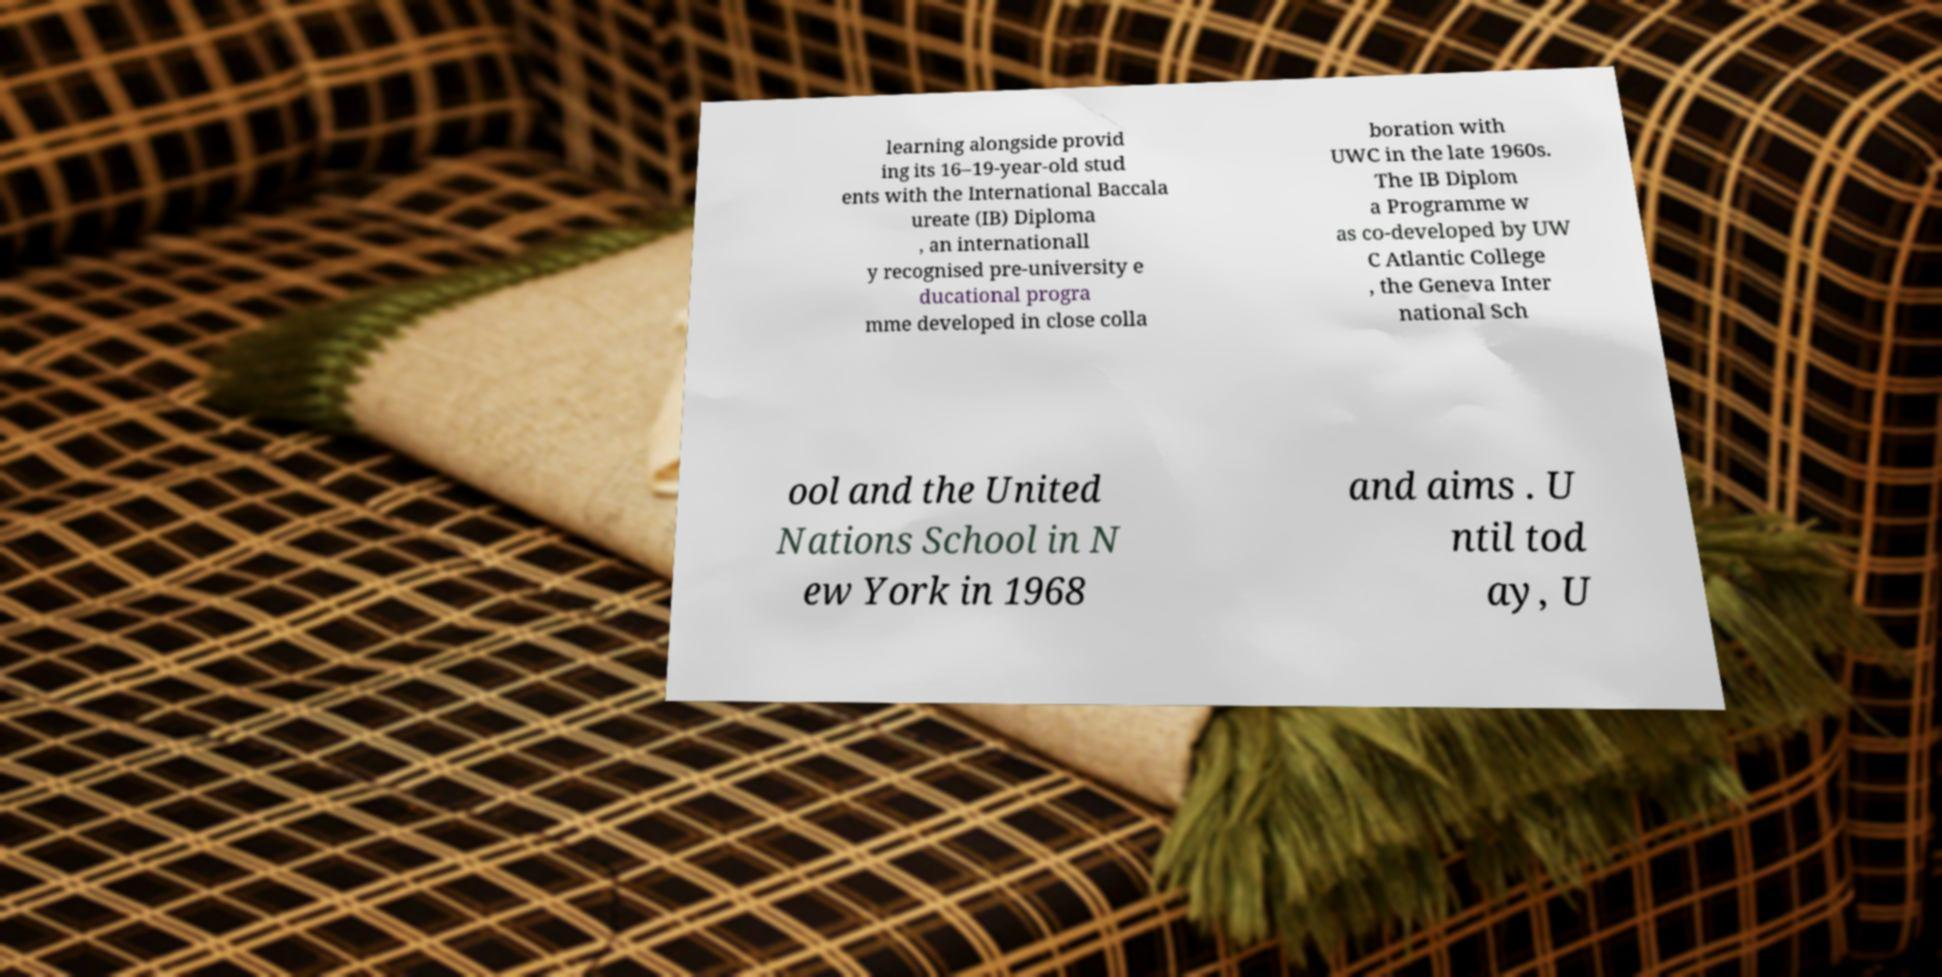For documentation purposes, I need the text within this image transcribed. Could you provide that? learning alongside provid ing its 16–19-year-old stud ents with the International Baccala ureate (IB) Diploma , an internationall y recognised pre-university e ducational progra mme developed in close colla boration with UWC in the late 1960s. The IB Diplom a Programme w as co-developed by UW C Atlantic College , the Geneva Inter national Sch ool and the United Nations School in N ew York in 1968 and aims . U ntil tod ay, U 